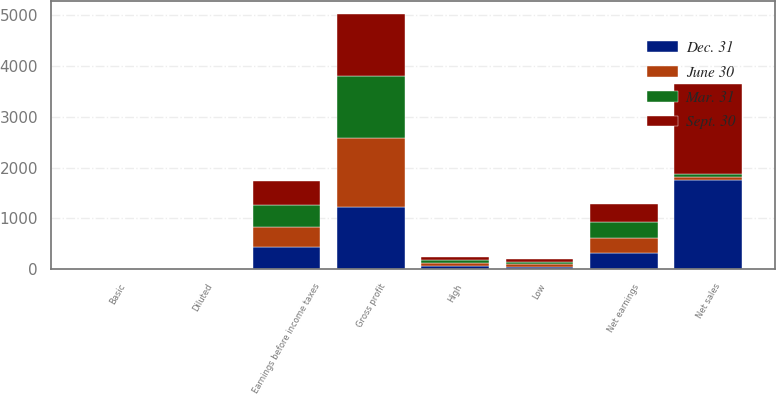Convert chart. <chart><loc_0><loc_0><loc_500><loc_500><stacked_bar_chart><ecel><fcel>Net sales<fcel>Gross profit<fcel>Earnings before income taxes<fcel>Net earnings<fcel>Basic<fcel>Diluted<fcel>High<fcel>Low<nl><fcel>Mar. 31<fcel>59.105<fcel>1217.7<fcel>445.8<fcel>321.7<fcel>0.81<fcel>0.8<fcel>58.49<fcel>49.85<nl><fcel>Dec. 31<fcel>1758.2<fcel>1218.9<fcel>442.6<fcel>319<fcel>0.8<fcel>0.8<fcel>59.72<fcel>48.76<nl><fcel>Sept. 30<fcel>1767.6<fcel>1226.8<fcel>461.9<fcel>337.7<fcel>0.85<fcel>0.85<fcel>53.29<fcel>42.74<nl><fcel>June 30<fcel>59.105<fcel>1370.9<fcel>379.3<fcel>295<fcel>0.75<fcel>0.74<fcel>55<fcel>48.13<nl></chart> 